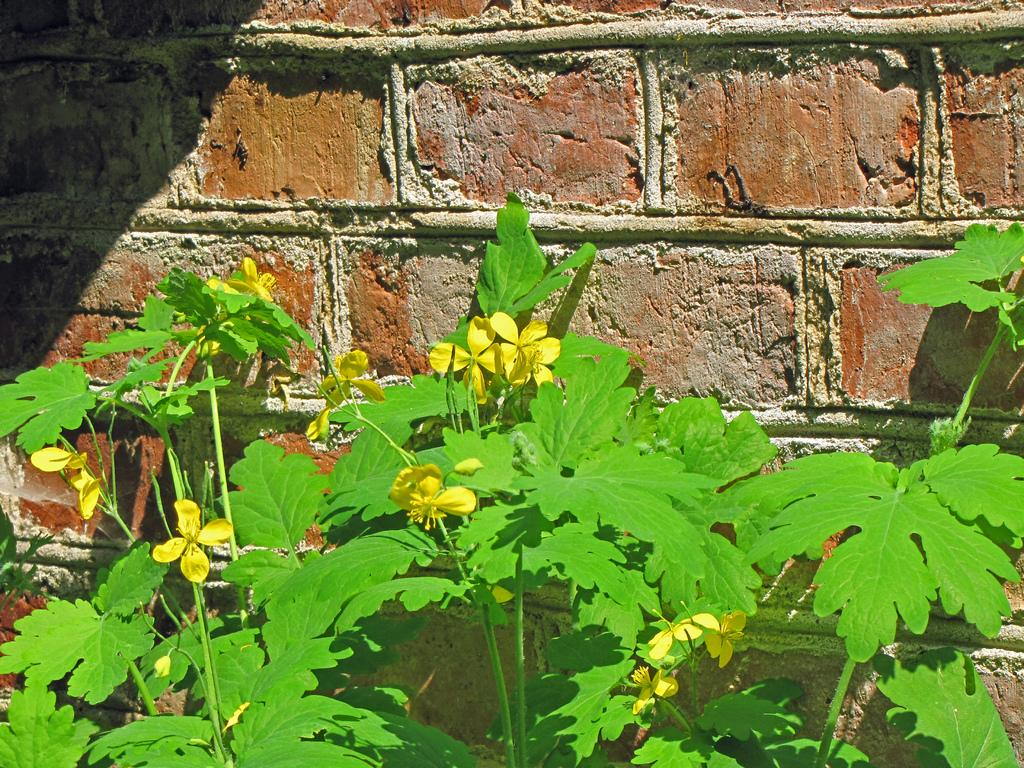What type of living organisms can be seen in the image? There are plants with flowers in the image. Where are the plants and flowers located in the image? The plants and flowers are located at the bottom of the image. What can be seen in the background of the image? There is a wall in the background of the image. What type of button can be seen on the plants in the image? There are no buttons present on the plants in the image. How is the distribution of the plants and flowers arranged in the image? The distribution of the plants and flowers is not mentioned in the provided facts, so we cannot determine their arrangement in the image. 